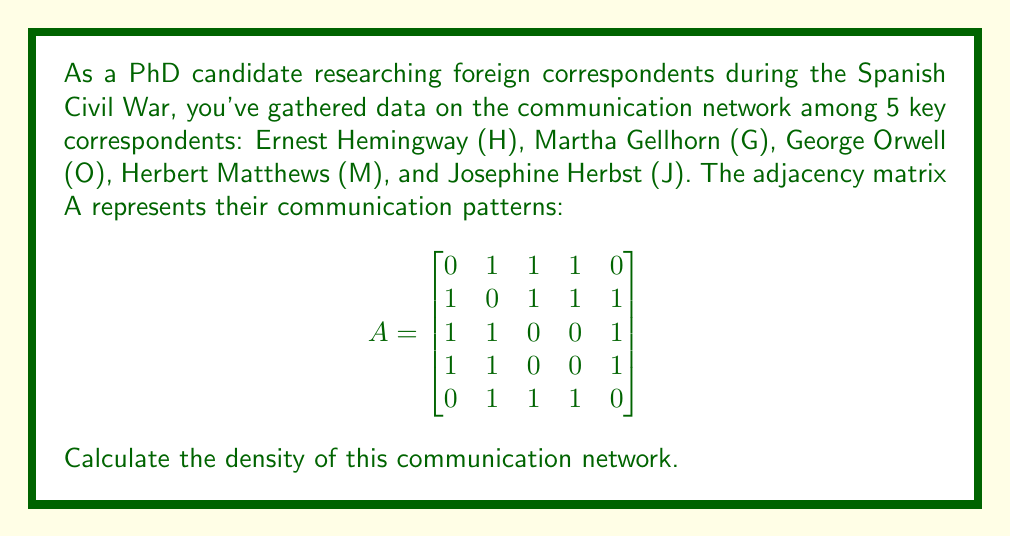Can you solve this math problem? To calculate the network density using the adjacency matrix, we'll follow these steps:

1) The network density is defined as the ratio of the actual number of connections to the maximum possible number of connections in the network.

2) For an undirected graph with $n$ nodes, the maximum number of possible connections is:

   $$\text{max connections} = \frac{n(n-1)}{2}$$

3) In this case, $n = 5$, so the maximum number of connections is:

   $$\frac{5(5-1)}{2} = \frac{5(4)}{2} = 10$$

4) To find the actual number of connections, we sum all entries in the upper (or lower) triangular part of the adjacency matrix and divide by 2 (since each connection is counted twice in an undirected graph).

5) The sum of the upper triangular part is:

   $1 + 1 + 1 + 0 + 1 + 1 + 1 + 1 + 1 + 1 = 9$

6) Dividing by 2 gives us the actual number of connections:

   $\frac{9}{2} = 4.5$

7) The network density is thus:

   $$\text{density} = \frac{\text{actual connections}}{\text{max possible connections}} = \frac{4.5}{10} = 0.45$$

Therefore, the density of this communication network is 0.45 or 45%.
Answer: 0.45 